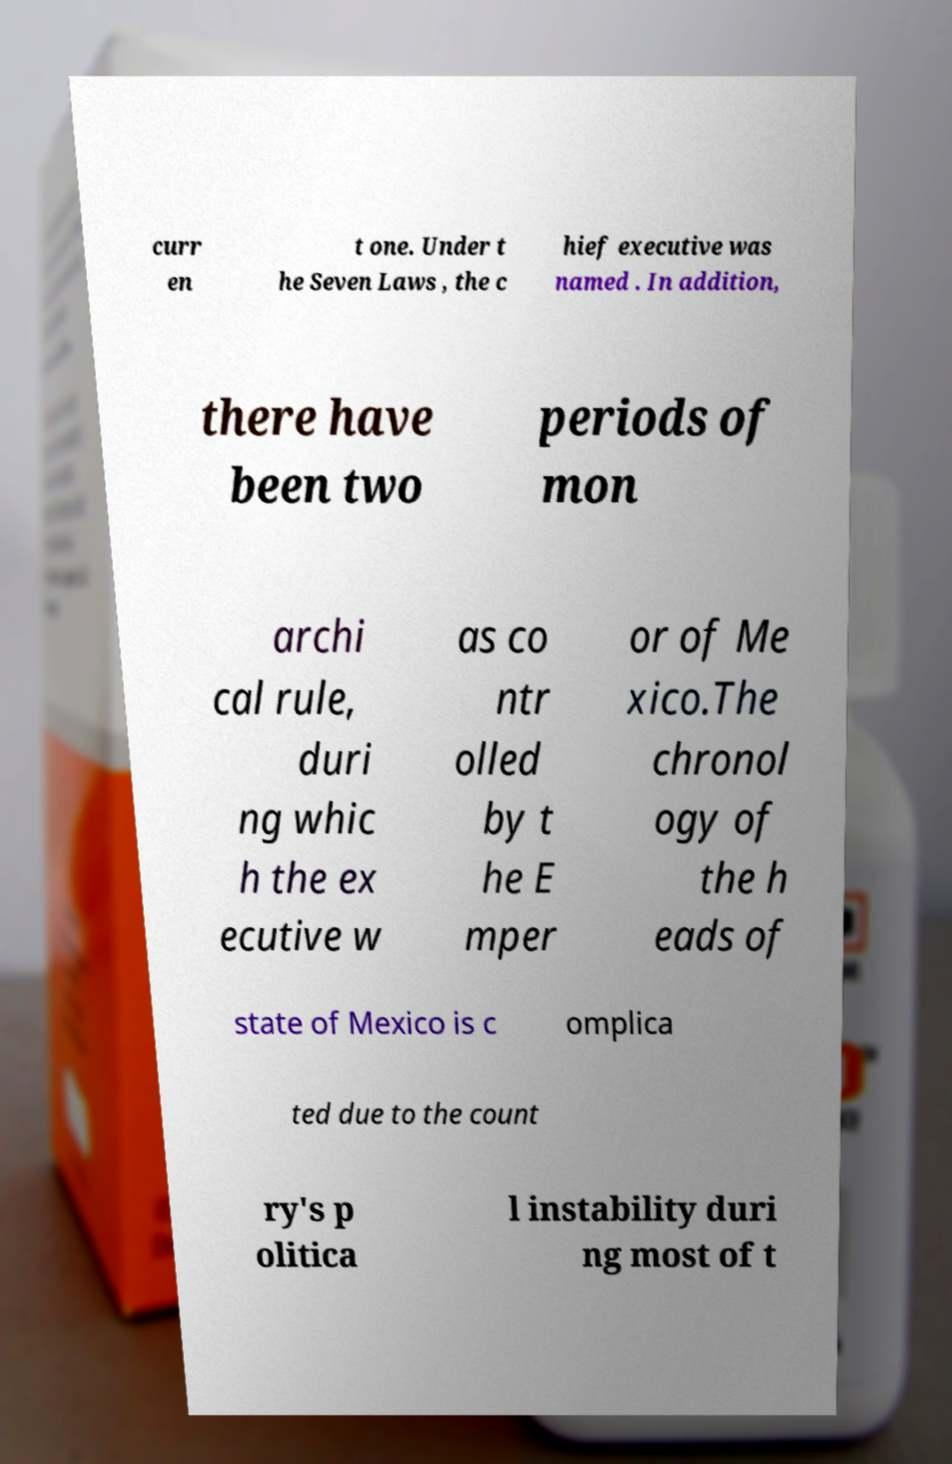Could you assist in decoding the text presented in this image and type it out clearly? curr en t one. Under t he Seven Laws , the c hief executive was named . In addition, there have been two periods of mon archi cal rule, duri ng whic h the ex ecutive w as co ntr olled by t he E mper or of Me xico.The chronol ogy of the h eads of state of Mexico is c omplica ted due to the count ry's p olitica l instability duri ng most of t 